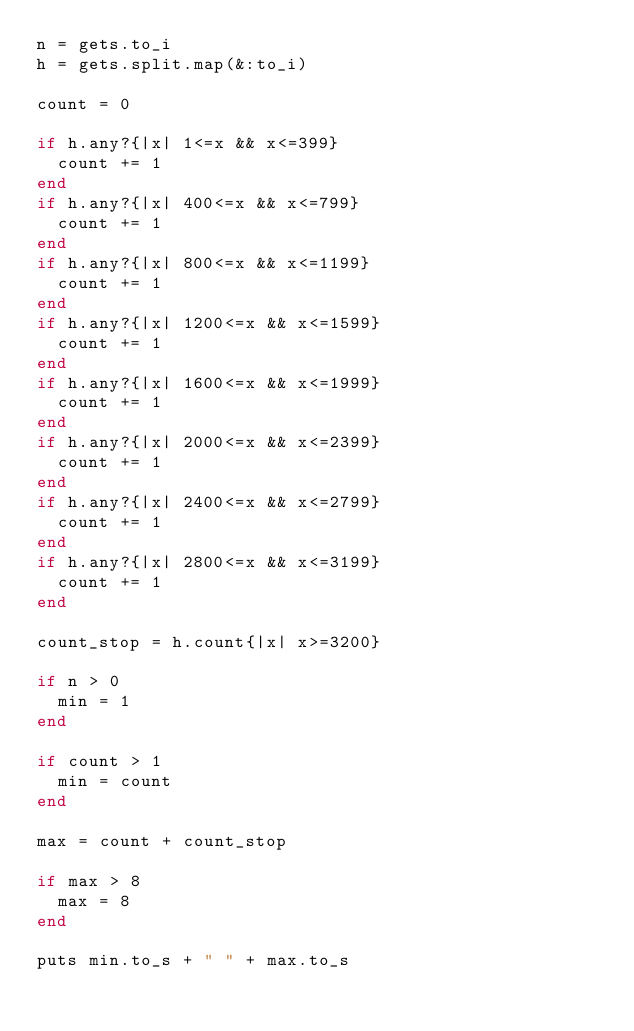Convert code to text. <code><loc_0><loc_0><loc_500><loc_500><_Ruby_>n = gets.to_i
h = gets.split.map(&:to_i)

count = 0

if h.any?{|x| 1<=x && x<=399}
  count += 1
end
if h.any?{|x| 400<=x && x<=799}
  count += 1
end
if h.any?{|x| 800<=x && x<=1199}
  count += 1
end
if h.any?{|x| 1200<=x && x<=1599}
  count += 1
end
if h.any?{|x| 1600<=x && x<=1999}
  count += 1
end
if h.any?{|x| 2000<=x && x<=2399}
  count += 1
end
if h.any?{|x| 2400<=x && x<=2799}
  count += 1
end
if h.any?{|x| 2800<=x && x<=3199}
  count += 1
end

count_stop = h.count{|x| x>=3200}

if n > 0
  min = 1
end

if count > 1
  min = count
end

max = count + count_stop

if max > 8
  max = 8
end

puts min.to_s + " " + max.to_s</code> 